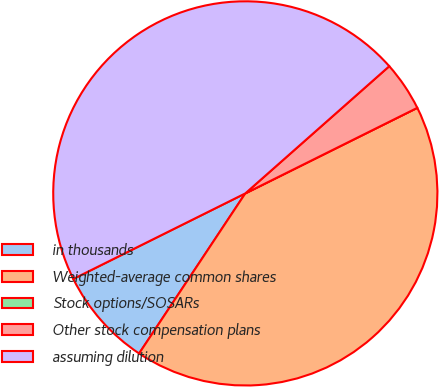Convert chart. <chart><loc_0><loc_0><loc_500><loc_500><pie_chart><fcel>in thousands<fcel>Weighted-average common shares<fcel>Stock options/SOSARs<fcel>Other stock compensation plans<fcel>assuming dilution<nl><fcel>8.33%<fcel>41.67%<fcel>0.0%<fcel>4.17%<fcel>45.83%<nl></chart> 